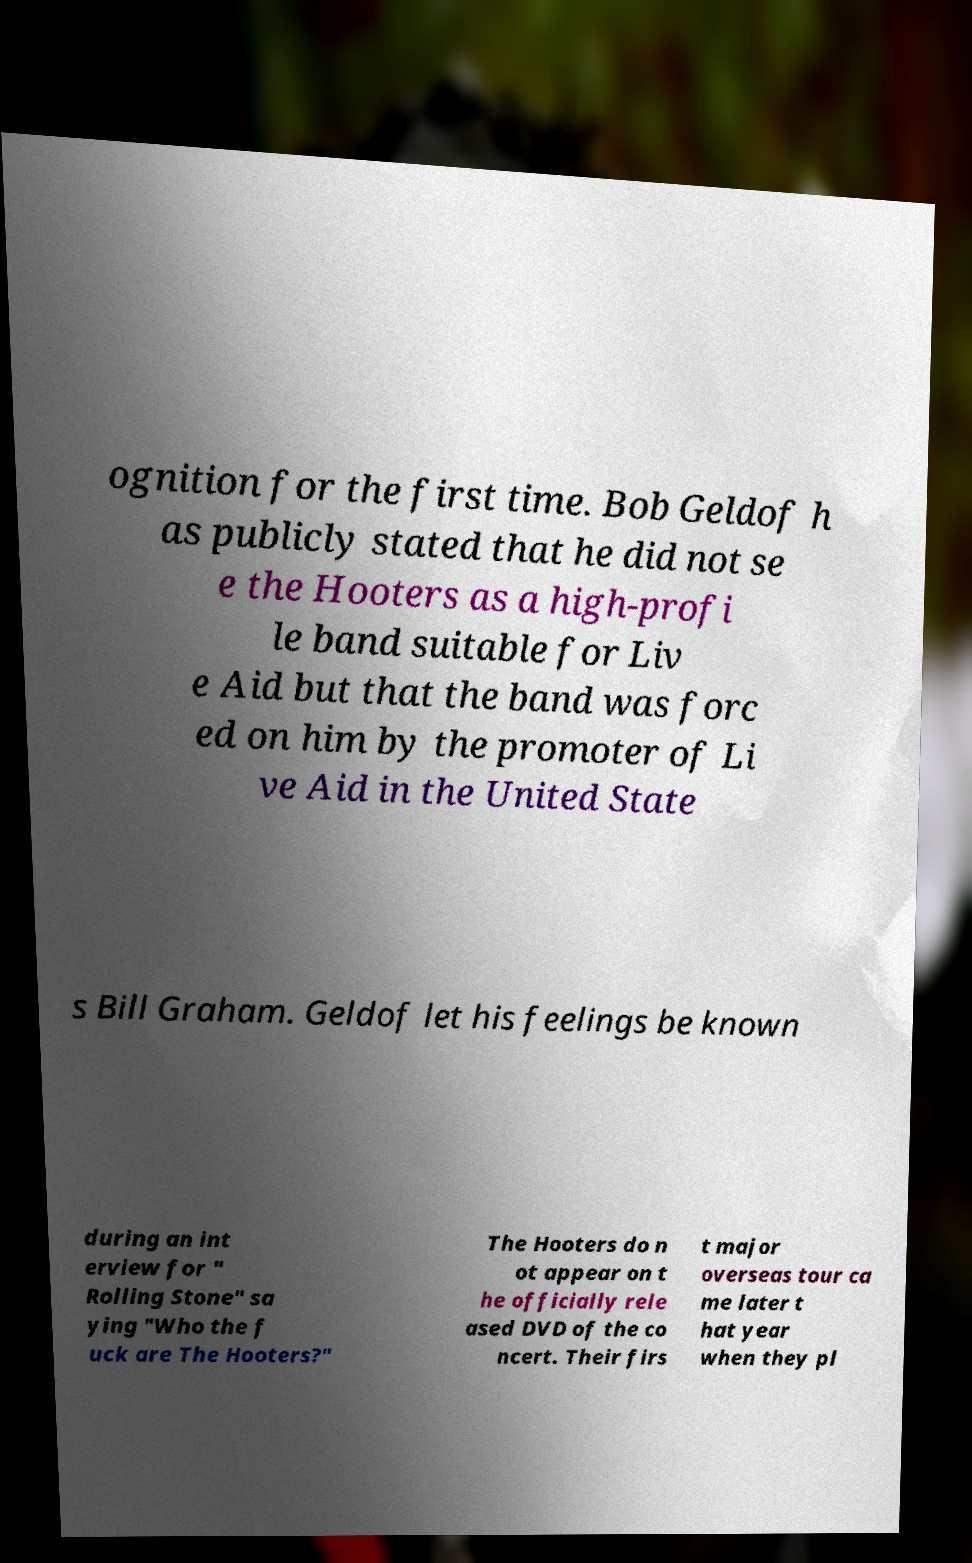What messages or text are displayed in this image? I need them in a readable, typed format. ognition for the first time. Bob Geldof h as publicly stated that he did not se e the Hooters as a high-profi le band suitable for Liv e Aid but that the band was forc ed on him by the promoter of Li ve Aid in the United State s Bill Graham. Geldof let his feelings be known during an int erview for " Rolling Stone" sa ying "Who the f uck are The Hooters?" The Hooters do n ot appear on t he officially rele ased DVD of the co ncert. Their firs t major overseas tour ca me later t hat year when they pl 